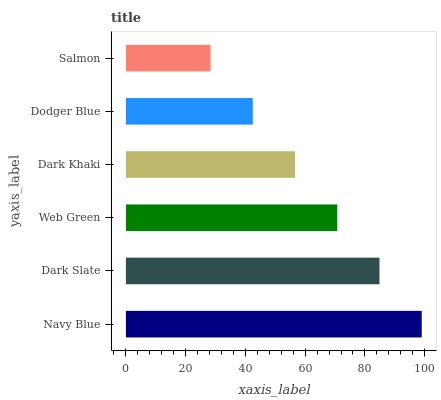Is Salmon the minimum?
Answer yes or no. Yes. Is Navy Blue the maximum?
Answer yes or no. Yes. Is Dark Slate the minimum?
Answer yes or no. No. Is Dark Slate the maximum?
Answer yes or no. No. Is Navy Blue greater than Dark Slate?
Answer yes or no. Yes. Is Dark Slate less than Navy Blue?
Answer yes or no. Yes. Is Dark Slate greater than Navy Blue?
Answer yes or no. No. Is Navy Blue less than Dark Slate?
Answer yes or no. No. Is Web Green the high median?
Answer yes or no. Yes. Is Dark Khaki the low median?
Answer yes or no. Yes. Is Dark Khaki the high median?
Answer yes or no. No. Is Dark Slate the low median?
Answer yes or no. No. 